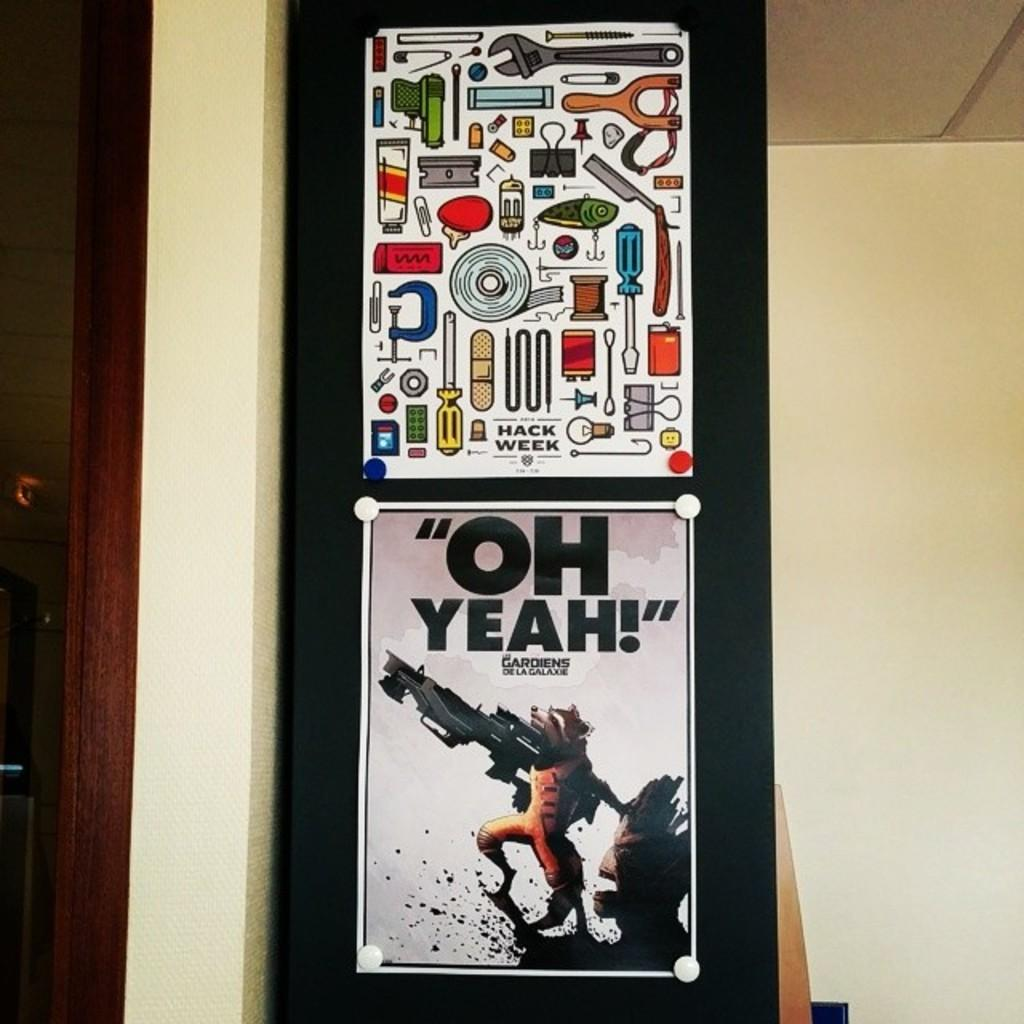<image>
Render a clear and concise summary of the photo. poster of rocket raccoon saying "oh yeah"  and another one that has drawings of different tools and gadgets 